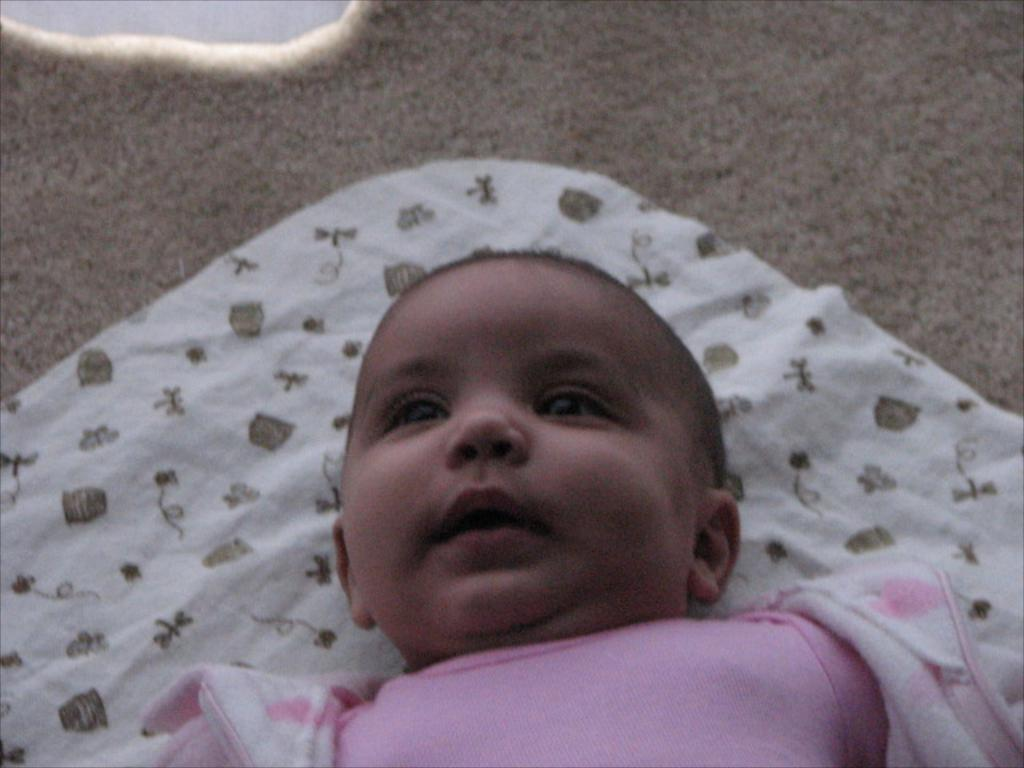What is the main subject of the image? The main subject of the image is a baby. What is the baby resting on in the image? The baby is on a cloth in the image. What type of invention is being used by the baby in the image? There is no invention present in the image; the baby is simply resting on a cloth. What type of yoke can be seen in the image? There is no yoke present in the image. 